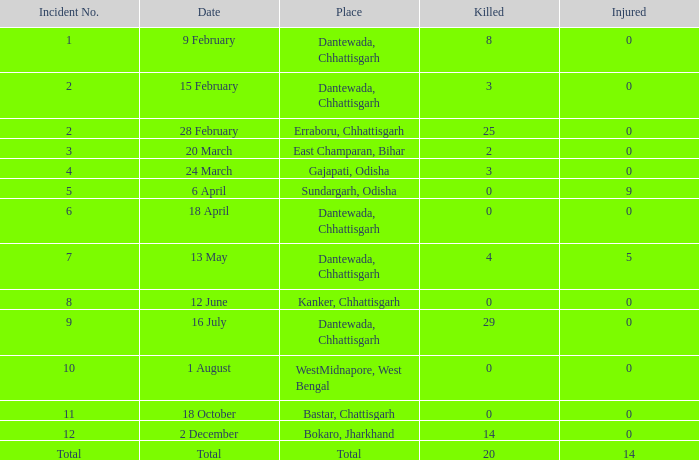What is the total count of injuries in east champaran, bihar when more than two fatalities occurred? 0.0. 